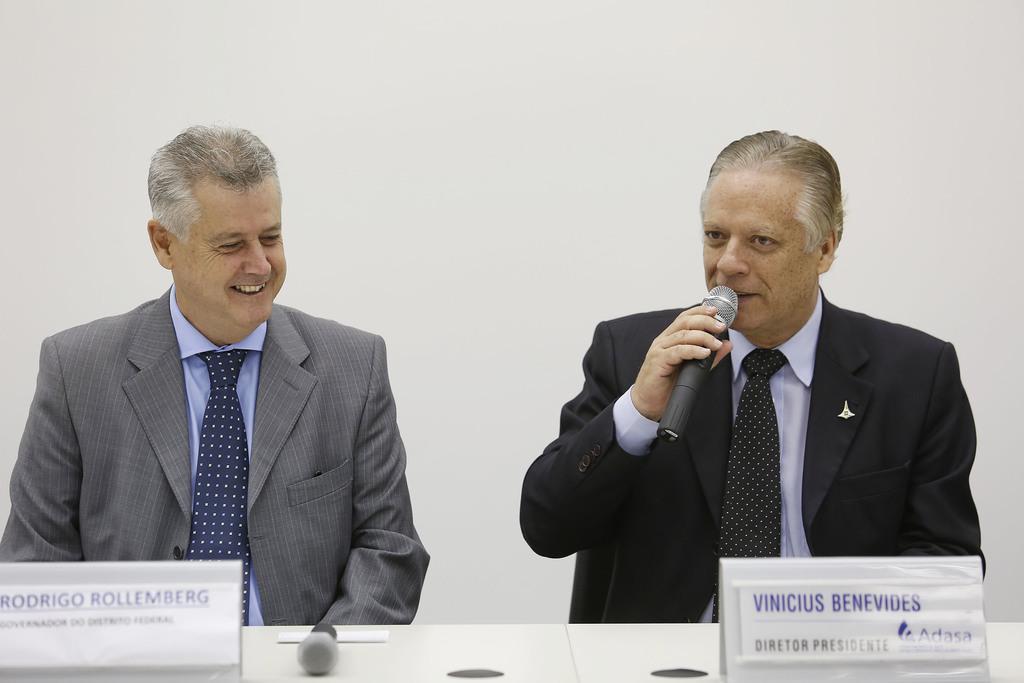Could you give a brief overview of what you see in this image? There are two men present in the middle of this image. We can see the right person is holding a Mike. There are text boards and a Mike present on the surface which is at the bottom of this image. We can see a wall in the background. 